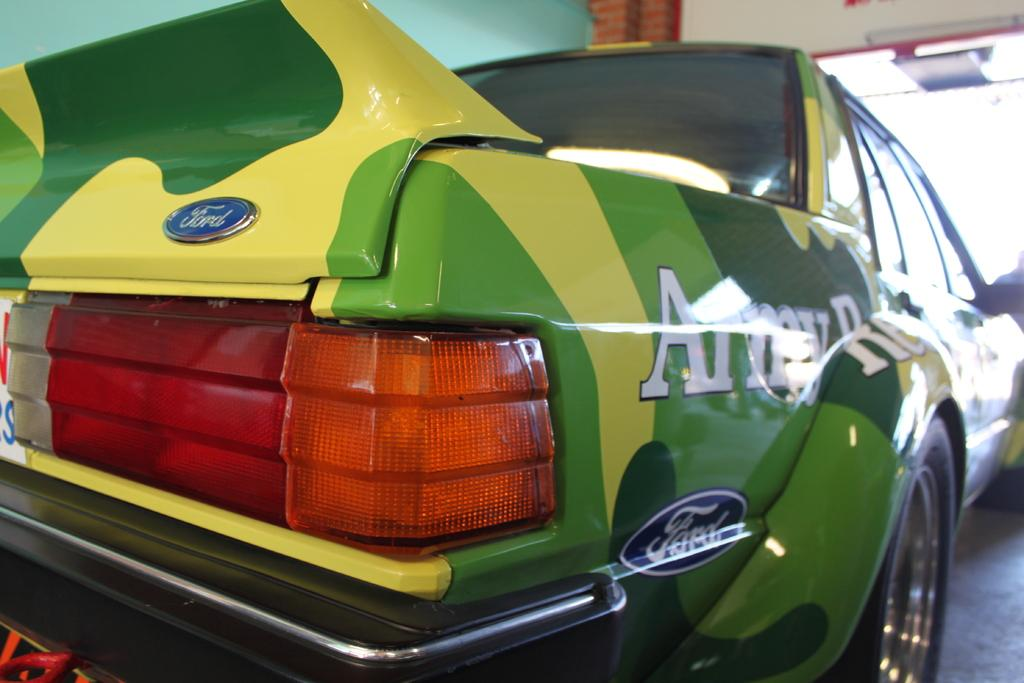What is the main subject of the image? The main subject of the image is a vehicle with a logo. Can you describe the position of the vehicle in the image? The vehicle is placed on a surface. What can be seen in the background of the image? There is a wall in the background of the image. How many kittens are sitting on the hood of the vehicle in the image? There are no kittens present in the image. What suggestion does the logo on the vehicle make to the viewer? The logo on the vehicle does not make any suggestions to the viewer, as it is a static image. 